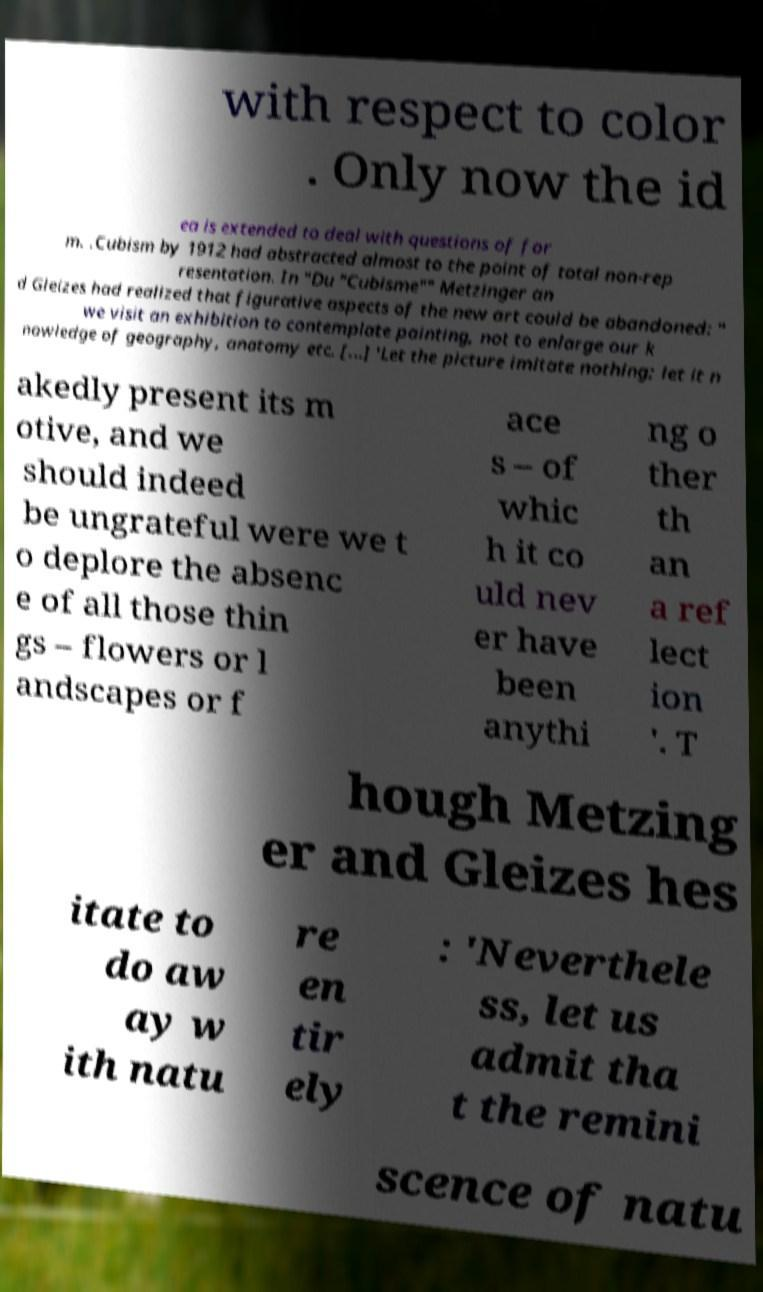What messages or text are displayed in this image? I need them in a readable, typed format. with respect to color . Only now the id ea is extended to deal with questions of for m. .Cubism by 1912 had abstracted almost to the point of total non-rep resentation. In "Du "Cubisme"" Metzinger an d Gleizes had realized that figurative aspects of the new art could be abandoned: " we visit an exhibition to contemplate painting, not to enlarge our k nowledge of geography, anatomy etc. [...] 'Let the picture imitate nothing; let it n akedly present its m otive, and we should indeed be ungrateful were we t o deplore the absenc e of all those thin gs – flowers or l andscapes or f ace s – of whic h it co uld nev er have been anythi ng o ther th an a ref lect ion '. T hough Metzing er and Gleizes hes itate to do aw ay w ith natu re en tir ely : 'Neverthele ss, let us admit tha t the remini scence of natu 